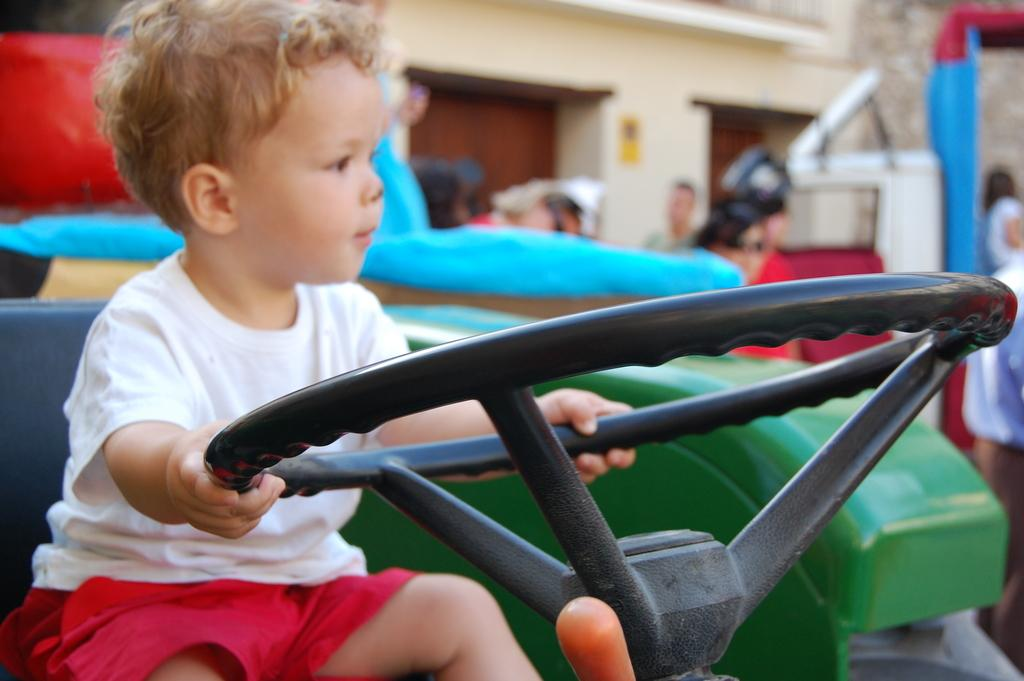Who is the main subject in the image? There is a boy in the image. What is the boy doing in the image? The boy is sitting in a vehicle and holding a steering wheel. What can be seen in the background of the image? There is a group of people, a house, and other items visible in the background of the image. What type of cherries can be seen growing on the apparatus in the image? There is no mention of cherries or an apparatus in the image; it features a boy sitting in a vehicle and holding a steering wheel, with a background that includes a group of people, a house, and other items. 